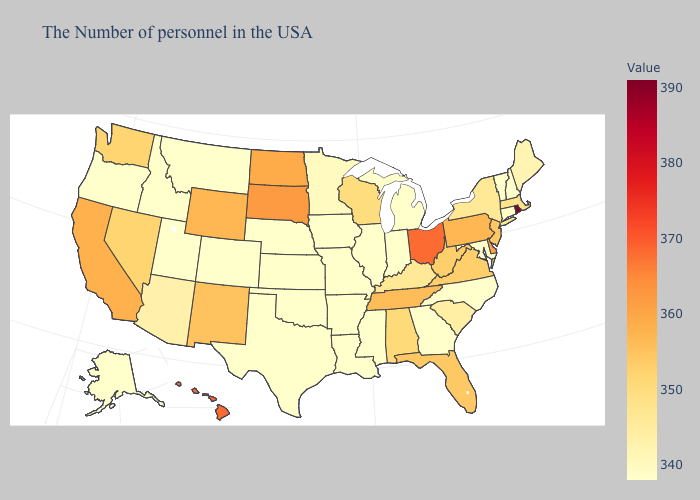Which states have the lowest value in the USA?
Write a very short answer. New Hampshire, Vermont, Connecticut, Maryland, North Carolina, Georgia, Michigan, Indiana, Illinois, Mississippi, Louisiana, Missouri, Arkansas, Iowa, Kansas, Nebraska, Oklahoma, Texas, Colorado, Utah, Montana, Idaho, Oregon, Alaska. Does Alaska have the lowest value in the West?
Quick response, please. Yes. Among the states that border Minnesota , which have the highest value?
Concise answer only. South Dakota. 